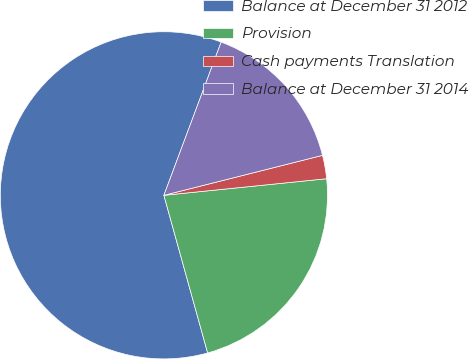<chart> <loc_0><loc_0><loc_500><loc_500><pie_chart><fcel>Balance at December 31 2012<fcel>Provision<fcel>Cash payments Translation<fcel>Balance at December 31 2014<nl><fcel>60.0%<fcel>22.31%<fcel>2.31%<fcel>15.38%<nl></chart> 